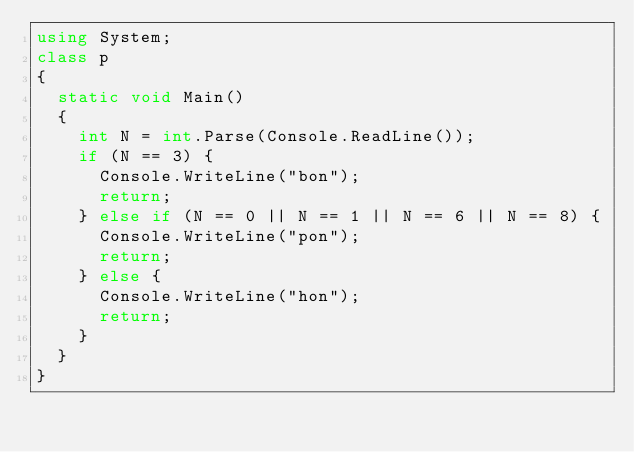<code> <loc_0><loc_0><loc_500><loc_500><_C#_>using System;
class p
{
  static void Main()
  {
    int N = int.Parse(Console.ReadLine());
    if (N == 3) {
      Console.WriteLine("bon");
      return;
    } else if (N == 0 || N == 1 || N == 6 || N == 8) {
      Console.WriteLine("pon");
      return;
    } else {
      Console.WriteLine("hon");
      return;
    }
  }
}</code> 